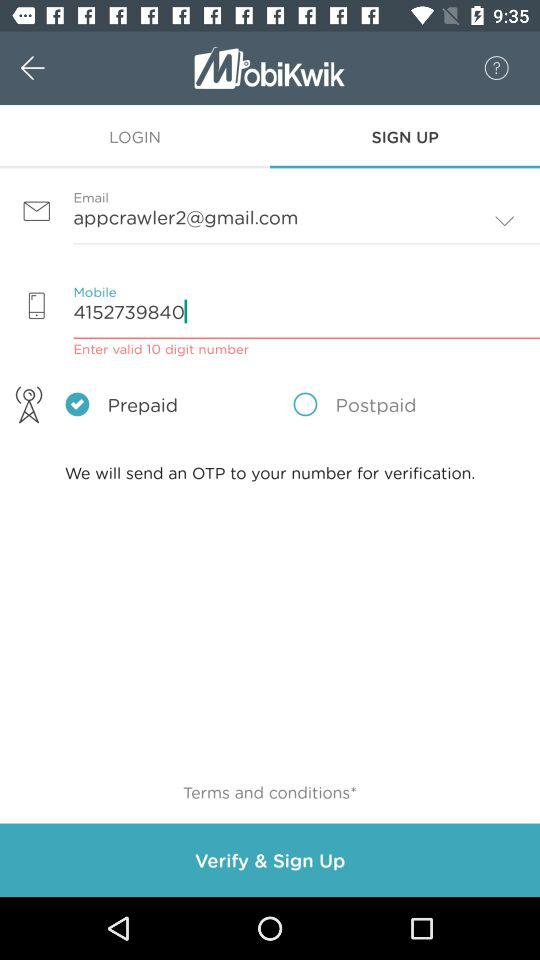Which tab is selected? The selected tab is "SIGN UP". 